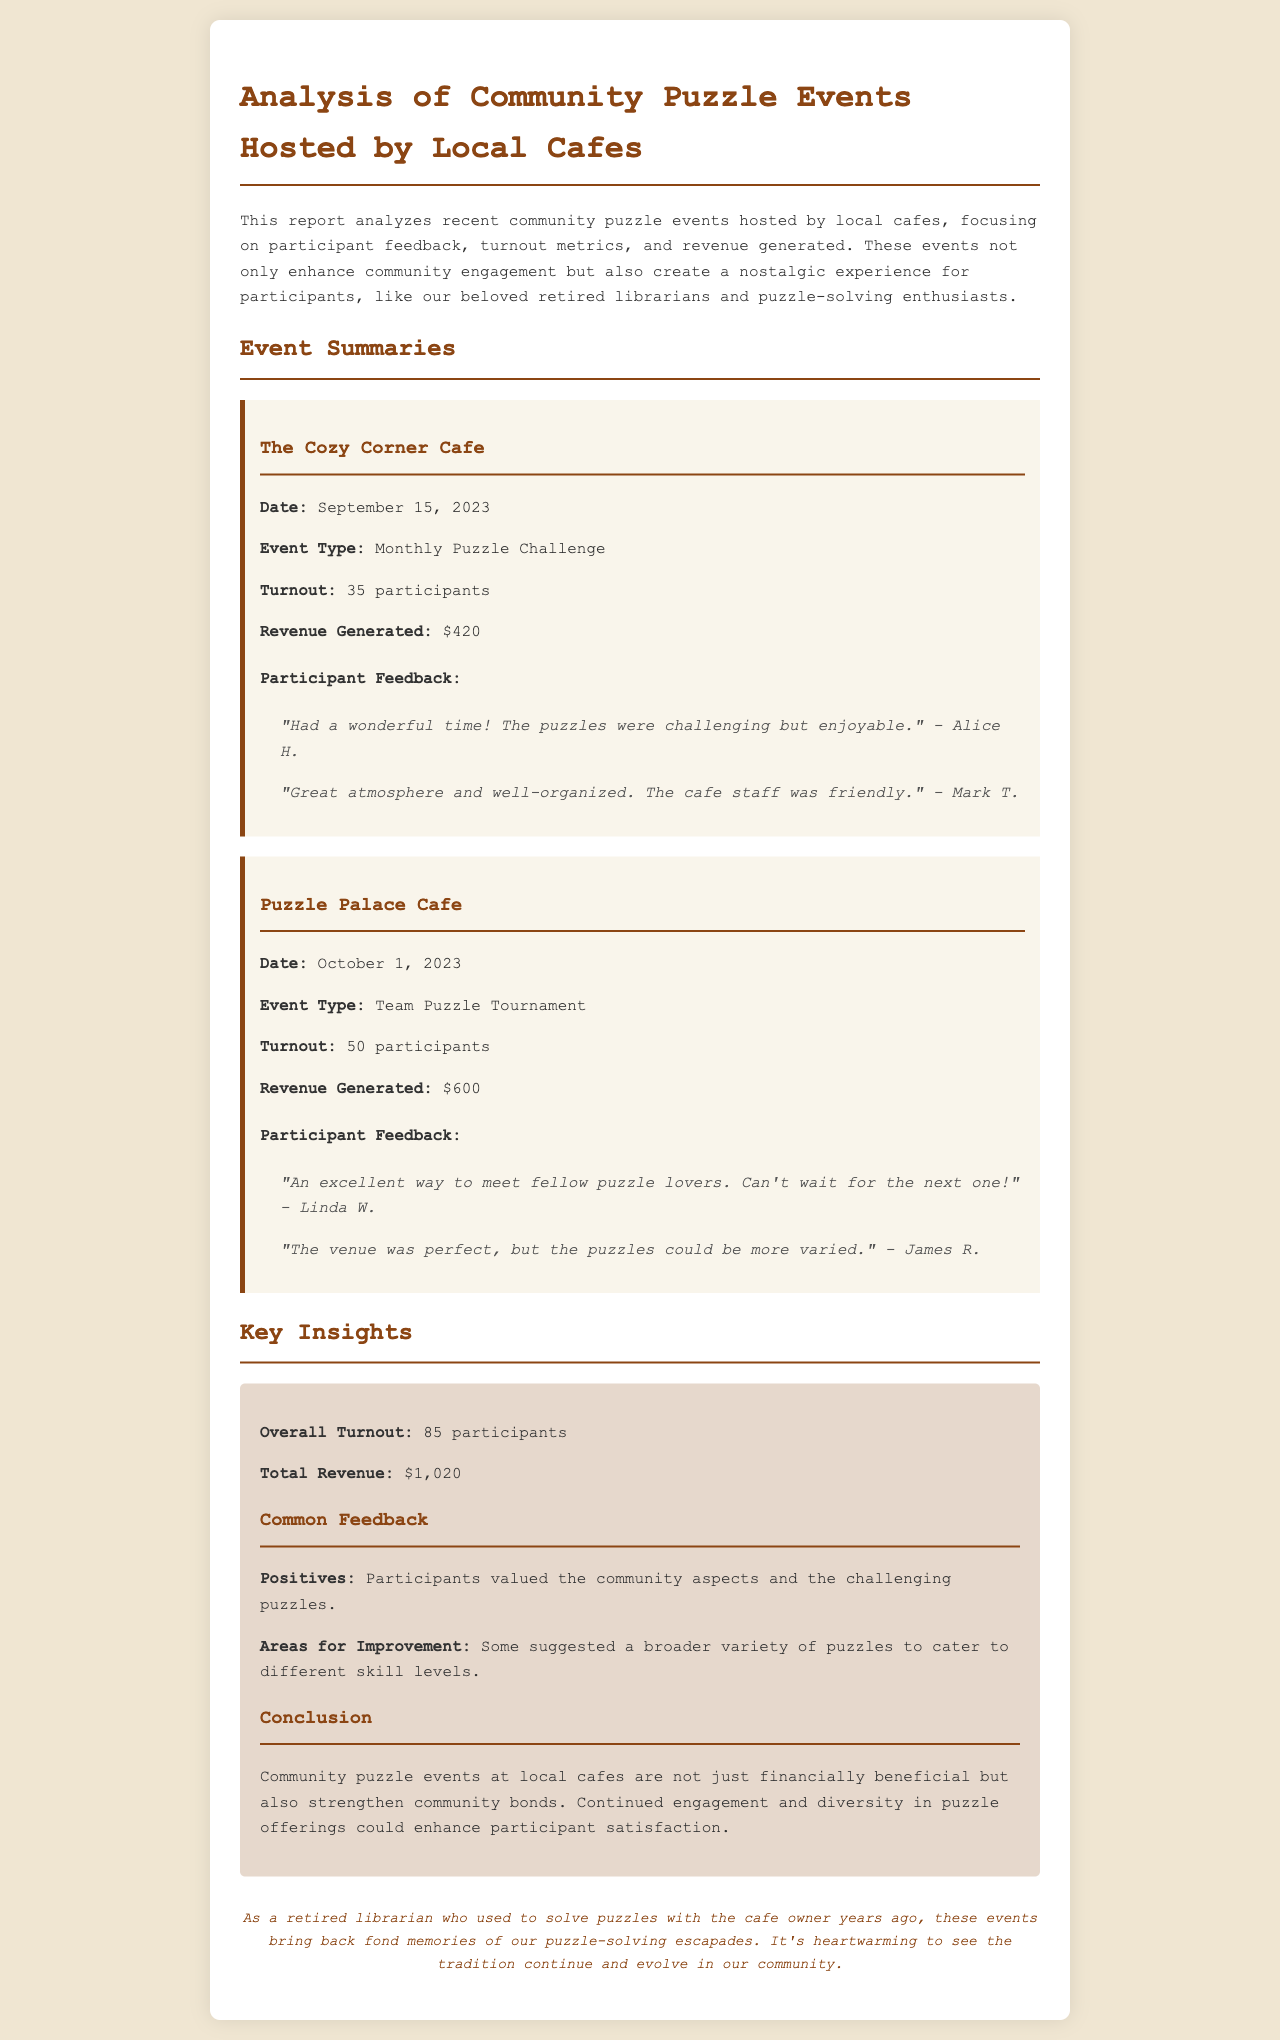What is the date of the event at The Cozy Corner Cafe? This information is specified in the event summary section for The Cozy Corner Cafe, which lists the date as September 15, 2023.
Answer: September 15, 2023 How many participants attended the Puzzle Palace Cafe event? The turnout for the Puzzle Palace Cafe event is mentioned directly in the event summary, indicating that there were 50 participants.
Answer: 50 participants What was the total revenue generated from both events? The total revenue is calculated by adding the revenue from both events, which are $420 and $600, resulting in a total of $1,020.
Answer: $1,020 What feedback did Linda W. provide? Linda W. provided specific feedback during the Puzzle Palace Cafe event, which states she found it an excellent way to meet fellow puzzle lovers and expressed eagerness for the next event.
Answer: "An excellent way to meet fellow puzzle lovers. Can't wait for the next one!" What is a common area for improvement mentioned by the participants? The document notes that some participants suggested the need for a broader variety of puzzles to cater to different skill levels, indicating a focus on enhancing future events.
Answer: Broader variety of puzzles 